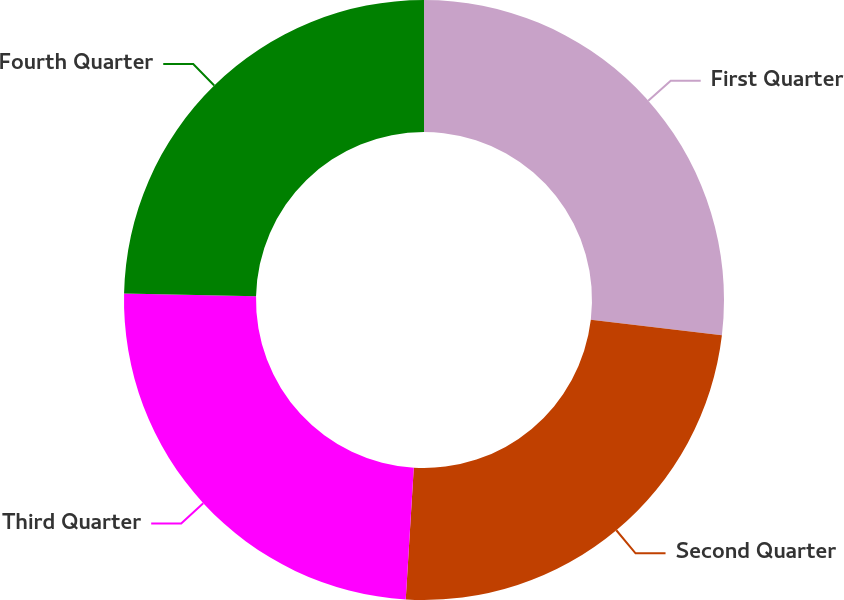<chart> <loc_0><loc_0><loc_500><loc_500><pie_chart><fcel>First Quarter<fcel>Second Quarter<fcel>Third Quarter<fcel>Fourth Quarter<nl><fcel>26.88%<fcel>24.09%<fcel>24.38%<fcel>24.65%<nl></chart> 